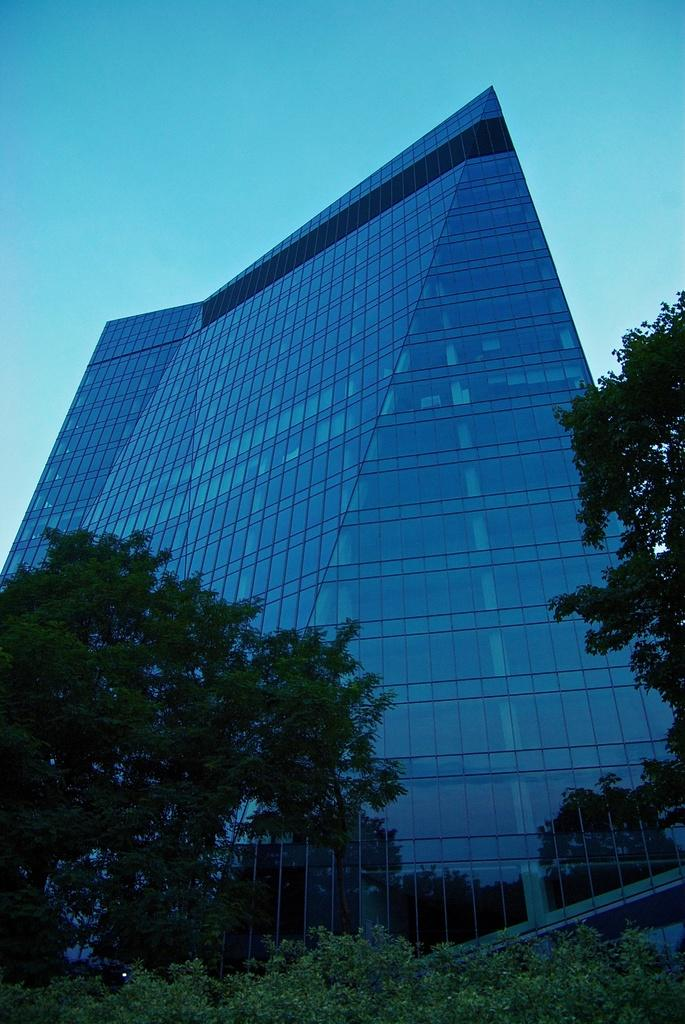What type of structure is present in the picture? There is a building in the picture. What other natural elements can be seen in the picture? There are trees in the picture. What part of the natural environment is visible in the picture? The sky is visible in the background of the picture. What type of skate is being used by the brain in the picture? There is no brain or skate present in the picture; it features a building and trees. 